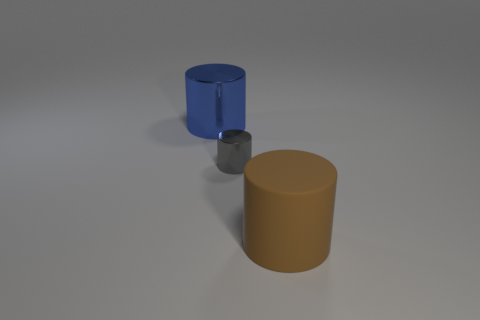Is there any other thing that is made of the same material as the brown cylinder?
Offer a terse response. No. Do the brown matte thing and the blue cylinder have the same size?
Offer a terse response. Yes. How many things are either gray things or gray cylinders on the left side of the brown thing?
Make the answer very short. 1. What color is the small metallic cylinder on the right side of the big cylinder that is behind the large brown matte cylinder?
Your answer should be very brief. Gray. What is the material of the big thing on the left side of the brown rubber object?
Give a very brief answer. Metal. What is the size of the blue cylinder?
Your answer should be compact. Large. Do the cylinder in front of the small gray thing and the gray cylinder have the same material?
Provide a short and direct response. No. How many blue objects are there?
Provide a succinct answer. 1. How many objects are either big brown metal cylinders or large cylinders?
Your response must be concise. 2. What number of big brown things are on the right side of the large cylinder behind the large cylinder that is right of the blue metal cylinder?
Give a very brief answer. 1. 